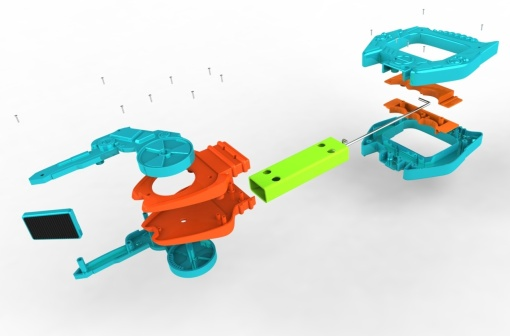What could be the impact of such a colorful design on the user experience? A colorful design like the one depicted in the image can significantly enhance the user experience. The vibrant colors can attract attention, evoke joy, and stimulate creativity. In a toy, such a design can make the assembling process more engaging and enjoyable, encouraging children to explore and learn through play. The use of contrasting colors also helps in distinguishing different parts, aiding in the assembly process and ensuring that it is both fun and educational. Can you think of a real-world scenario that this image might represent? Certainly. This image could represent an educational toy designed to teach children about engineering and mechanics. In a classroom setting, students might use this toy kit to learn about how different parts come together to form a functioning object, reinforcing concepts of design, structure, and assembly. The color-coded components could aid in understanding the role of each part, making the learning experience both interactive and visually stimulating. Describe a longer real-world scenario inspired by the image. Imagine a bustling workshop where a group of children, guided by a passionate instructor, is deeply engaged in a STEM (Science, Technology, Engineering, and Mathematics) activity. Each child is given a kit resembling the disassembled toy car in the image. The instructor explains the importance of each component, from the colorful body and wheels to the small but crucial screws. The room is filled with a sense of excitement as the children, working in teams, begin to assemble their cars. They learn collaboration, problem-solving, and the basics of engineering as they figure out how to fit pieces together. The floating screws in the image could symbolize the moments of realization and discovery, as each piece finds its place, culminating in the creation of a vibrant and functional toy car. This hands-on activity not only sparks interest in engineering but also fosters teamwork and creativity among the young participants. 